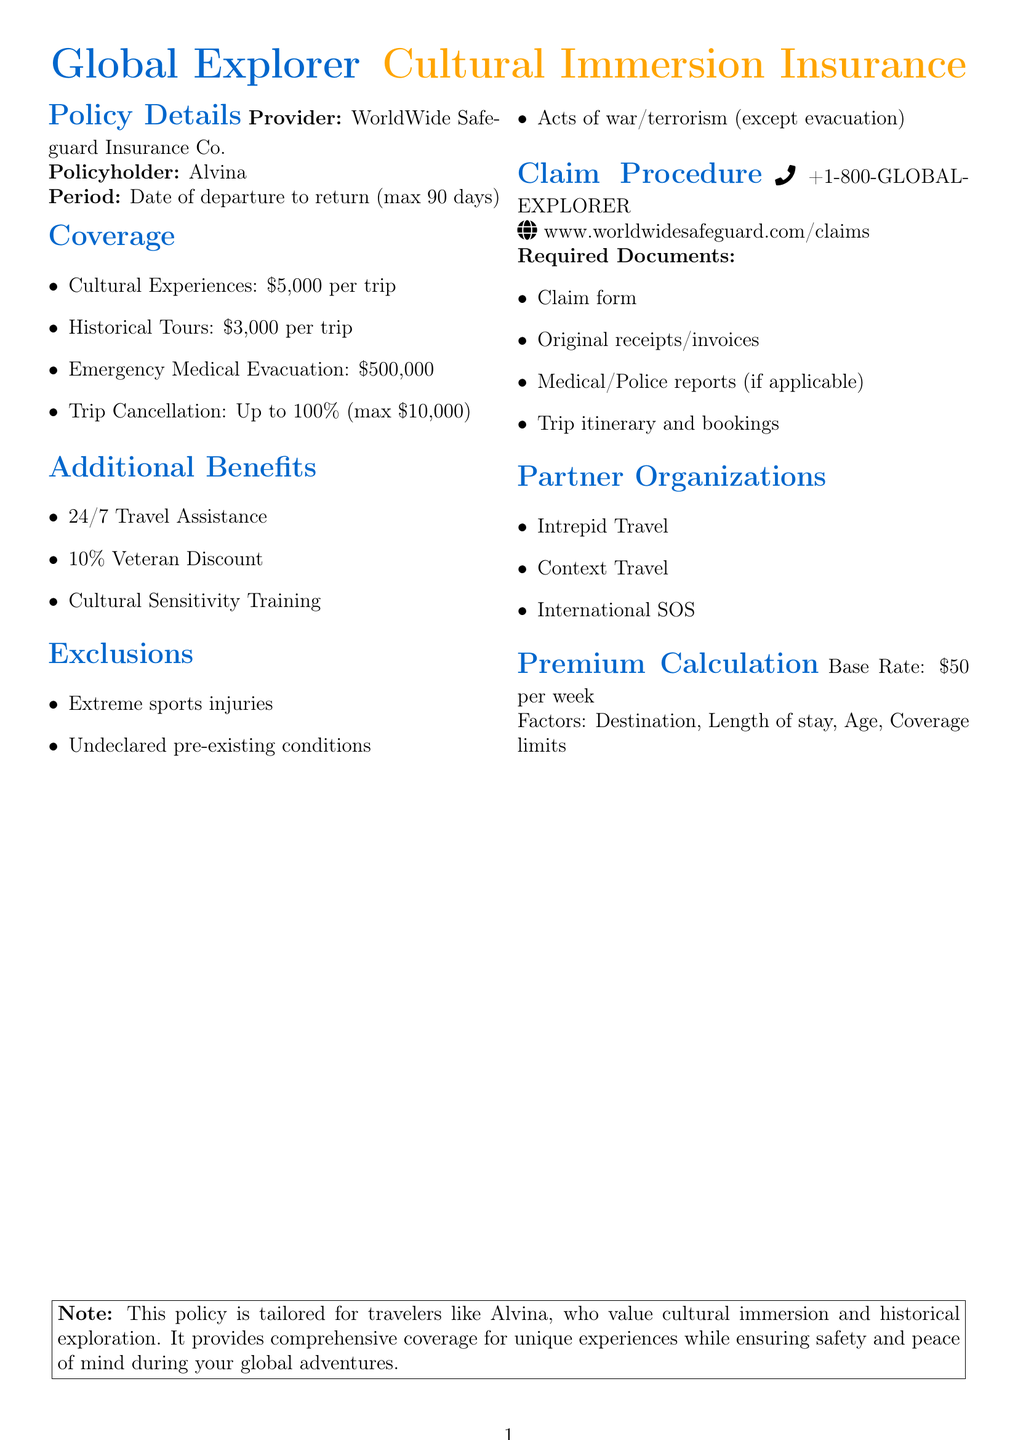What is the insurance provider's name? The insurance provider mentioned in the document is WorldWide Safeguard Insurance Co.
Answer: WorldWide Safeguard Insurance Co What is the coverage limit for cultural immersion experiences? The policy provides coverage for cultural immersion experiences up to $5,000 per trip.
Answer: $5,000 per trip What is the maximum reimbursement for trip cancellation? The document states that the maximum reimbursement for trip cancellation is $10,000.
Answer: $10,000 What benefit is offered to active duty military personnel and veterans? The document includes a 10% discount on the policy premium for active duty military personnel and veterans.
Answer: 10% discount What are the required documents for the claim procedure? The required documents include a completed claim form, original receipts, and medical reports if applicable.
Answer: Completed claim form, original receipts, medical reports What types of exclusions are mentioned in the policy? The exclusions listed include injuries from extreme sports and undeclared pre-existing conditions.
Answer: Extreme sports injuries, undeclared pre-existing conditions What is the period of the policy coverage? The policy coverage period starts from the date of departure to the date of return, with a maximum of 90 days.
Answer: Date of departure to date of return (maximum 90 days) What is the base rate for the premium calculation? The base rate for the premium calculation is $50 per week.
Answer: $50 per week Which organization offers small group adventure tours? The partner organization offering small group adventure tours is Intrepid Travel.
Answer: Intrepid Travel 